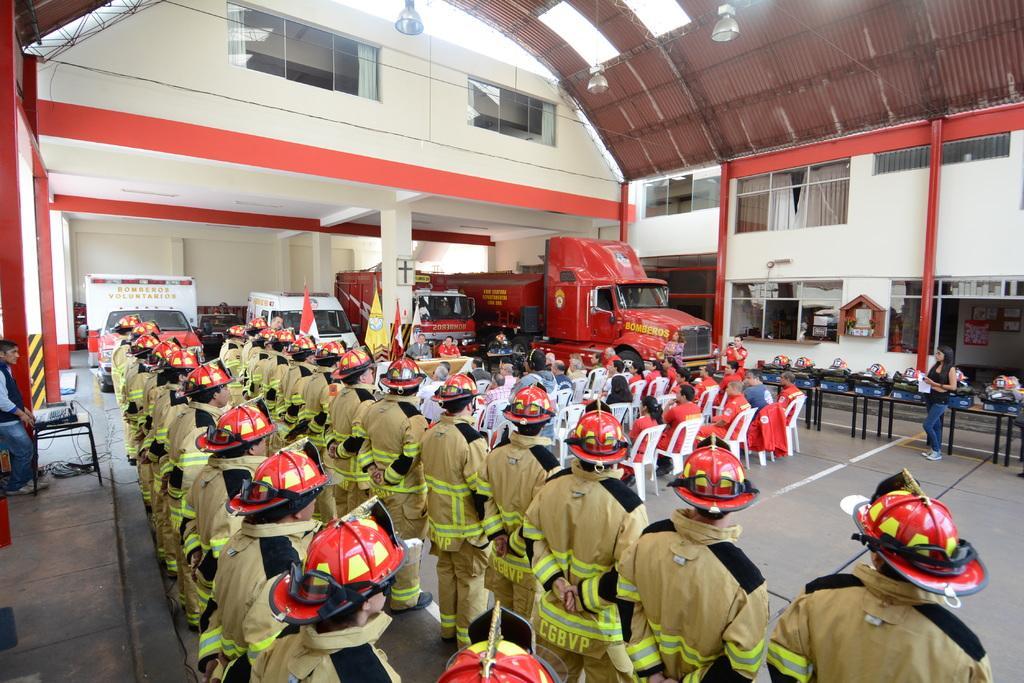Describe this image in one or two sentences. In the picture there are many people standing in an order in two rows and in front of those people some audience are sitting on the chairs and in front of them there are two men sitting in front of the table and behind the men there are few flags and behind the flag there are four vehicles,there is a roof above these people and around the roof there are two buildings. 